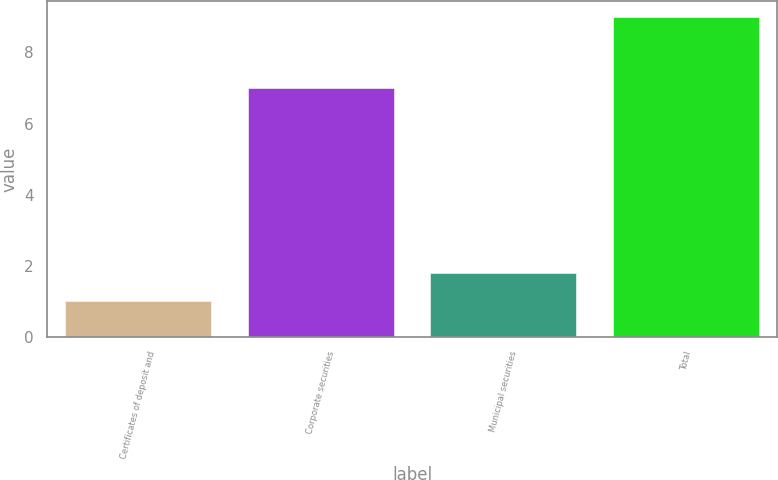Convert chart to OTSL. <chart><loc_0><loc_0><loc_500><loc_500><bar_chart><fcel>Certificates of deposit and<fcel>Corporate securities<fcel>Municipal securities<fcel>Total<nl><fcel>1<fcel>7<fcel>1.8<fcel>9<nl></chart> 